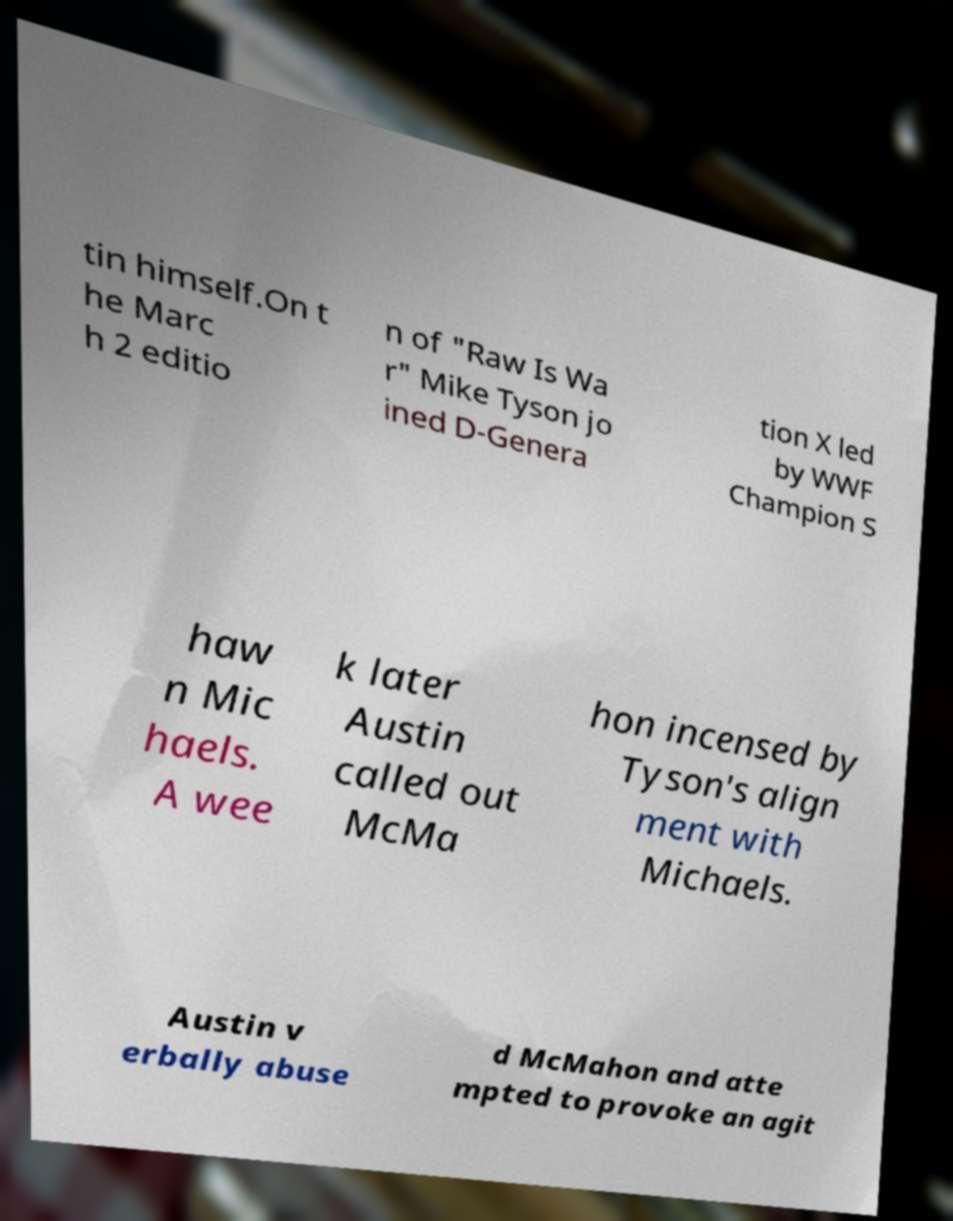What messages or text are displayed in this image? I need them in a readable, typed format. tin himself.On t he Marc h 2 editio n of "Raw Is Wa r" Mike Tyson jo ined D-Genera tion X led by WWF Champion S haw n Mic haels. A wee k later Austin called out McMa hon incensed by Tyson's align ment with Michaels. Austin v erbally abuse d McMahon and atte mpted to provoke an agit 